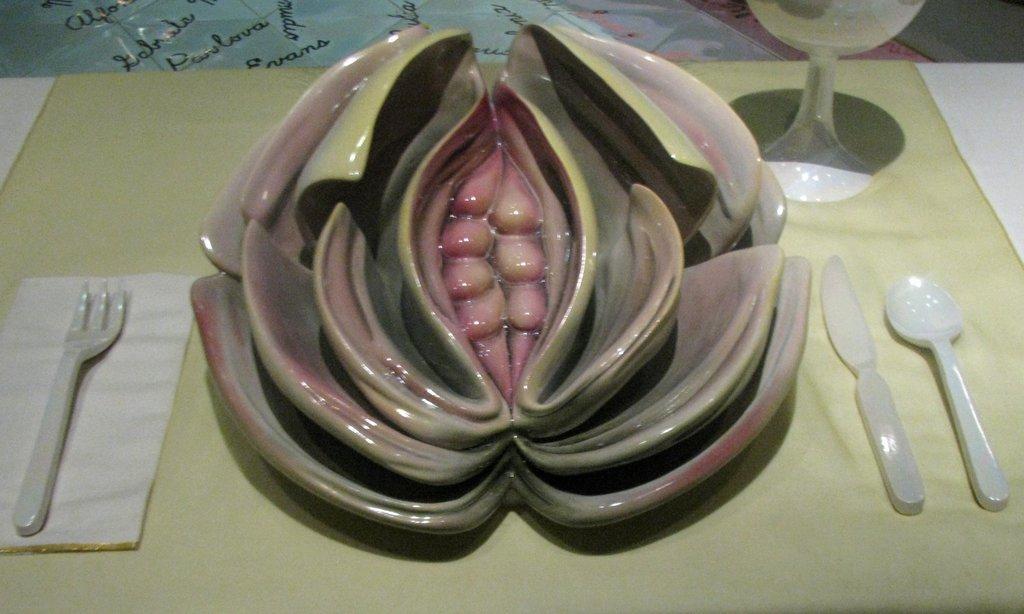Please provide a concise description of this image. In this image i can see a bowl, few spoons a cup on the table. 